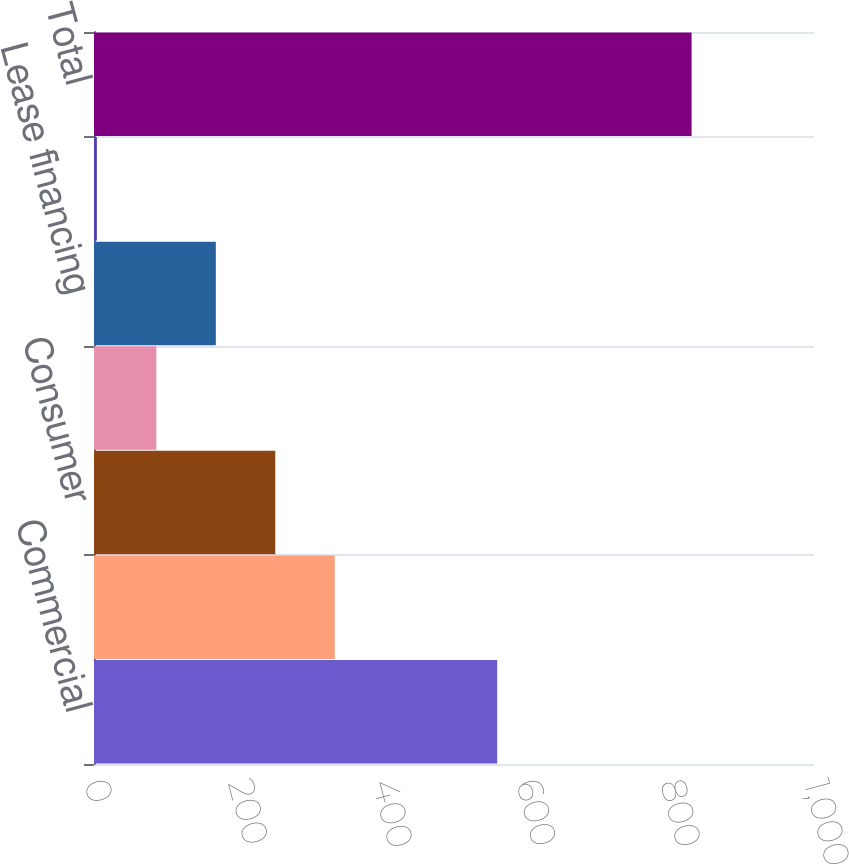Convert chart to OTSL. <chart><loc_0><loc_0><loc_500><loc_500><bar_chart><fcel>Commercial<fcel>Commercial real estate<fcel>Consumer<fcel>Residential mortgage<fcel>Lease financing<fcel>Other<fcel>Total<nl><fcel>560<fcel>334.4<fcel>251.8<fcel>86.6<fcel>169.2<fcel>4<fcel>830<nl></chart> 